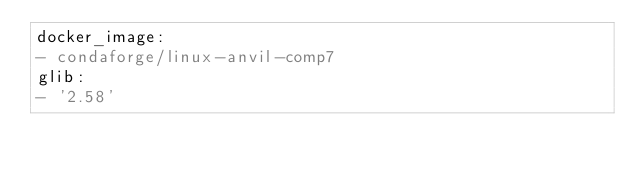Convert code to text. <code><loc_0><loc_0><loc_500><loc_500><_YAML_>docker_image:
- condaforge/linux-anvil-comp7
glib:
- '2.58'
</code> 